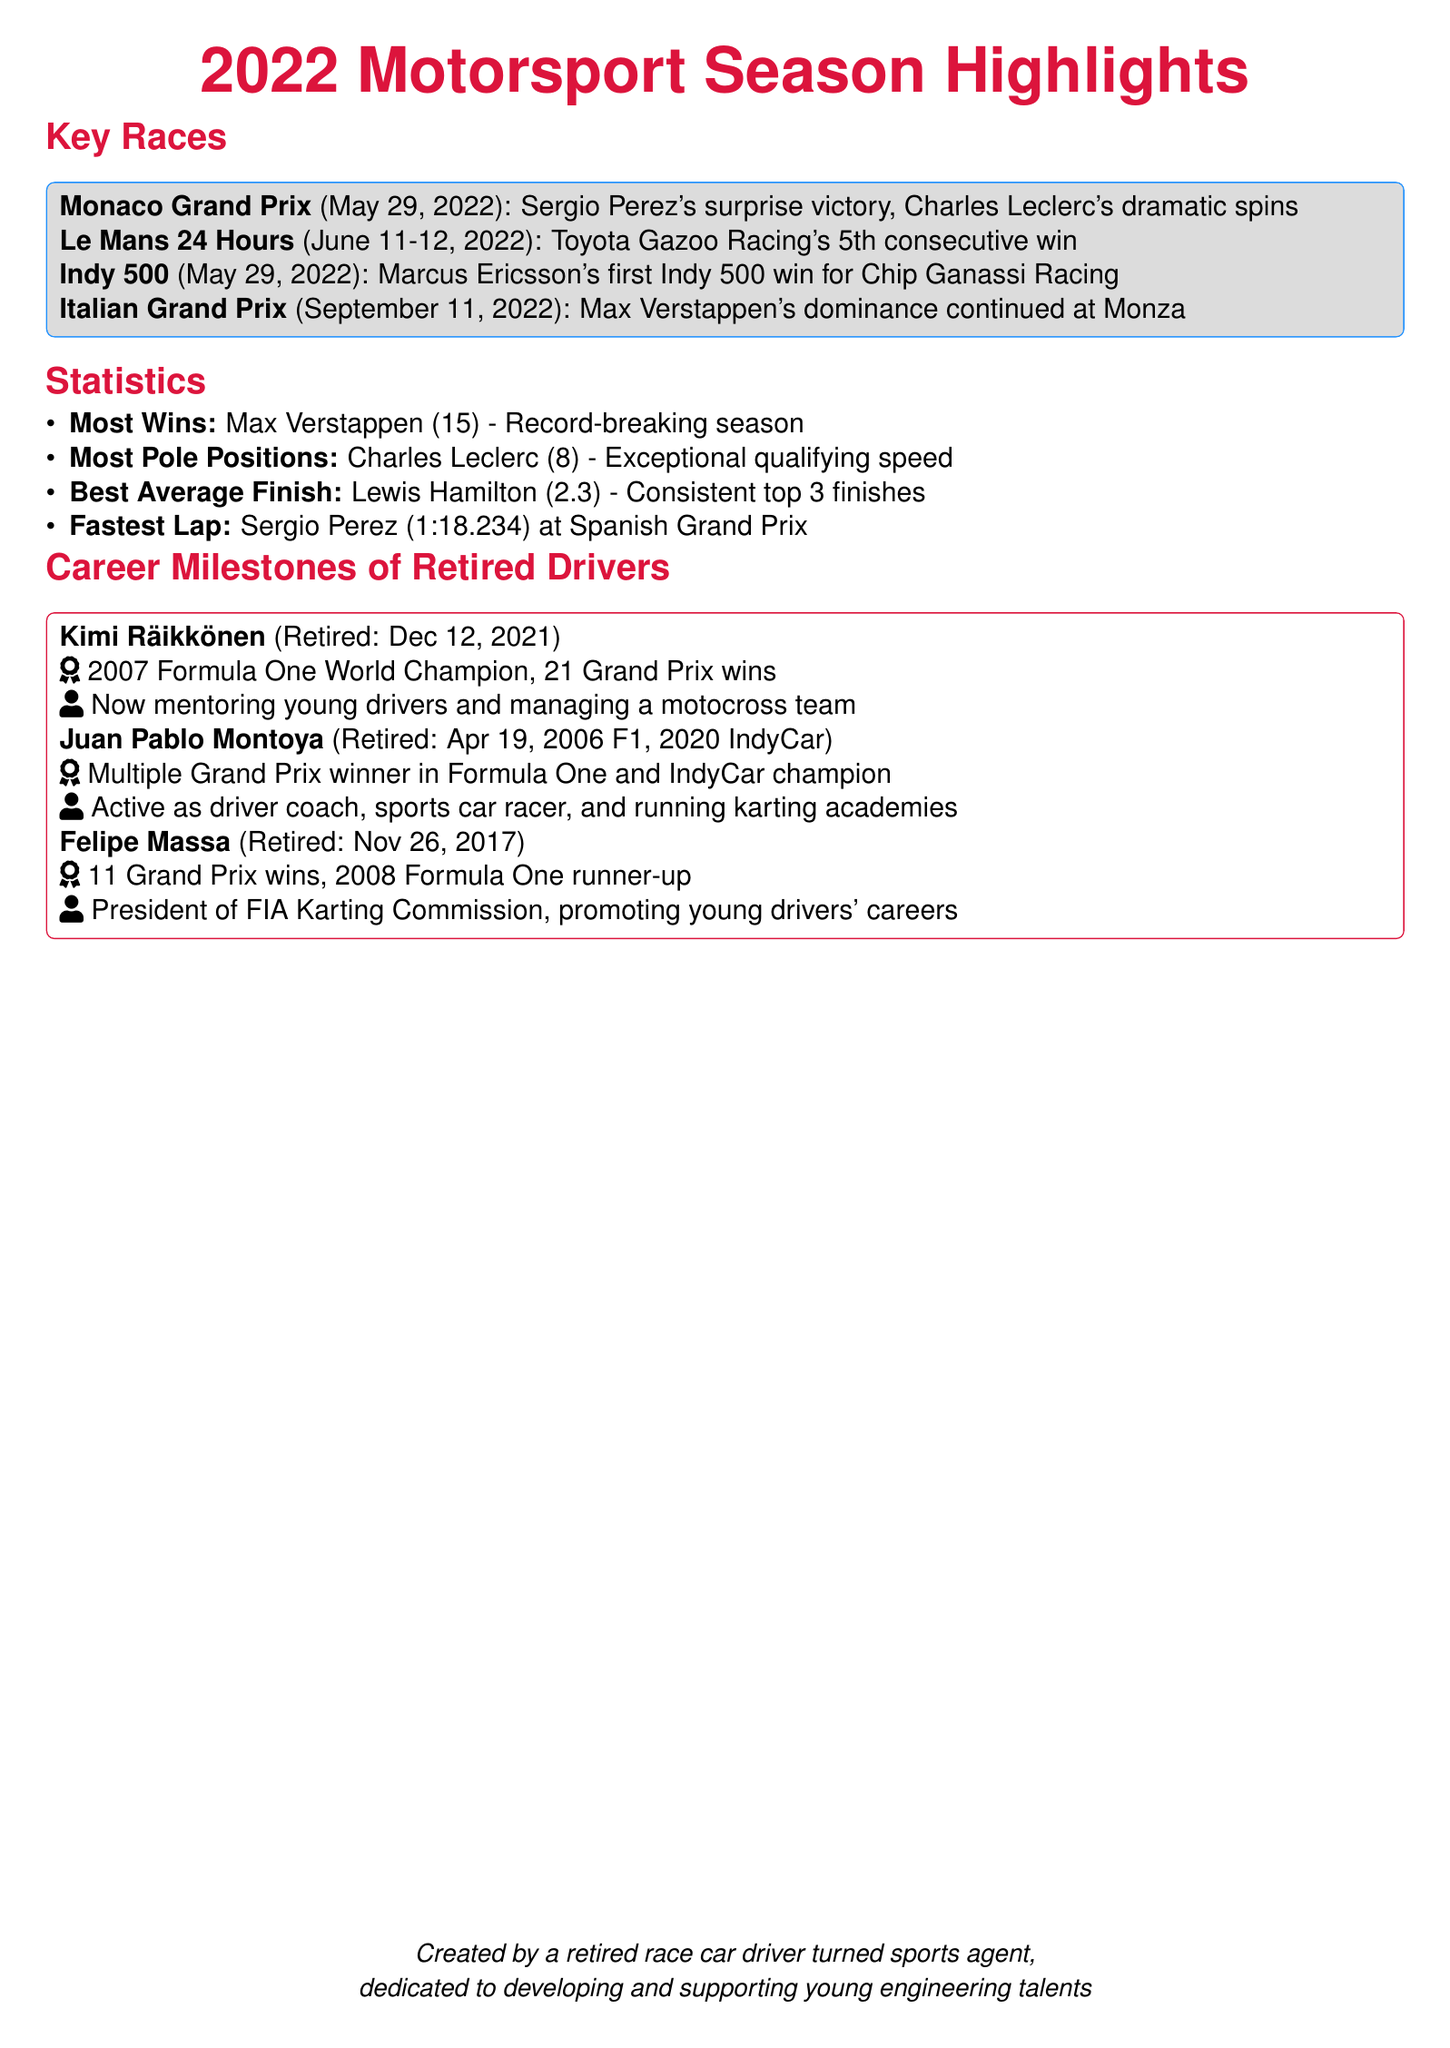What was the surprise victory at the Monaco Grand Prix? Sergio Perez's unexpected win is highlighted in the key races section.
Answer: Sergio Perez Who had the most pole positions in 2022? The statistics section states that Charles Leclerc had the most pole positions.
Answer: Charles Leclerc What significant race took place on May 29, 2022? The document lists both the Monaco Grand Prix and Indy 500 occurring on this date.
Answer: Indy 500 How many wins did Max Verstappen achieve in the 2022 season? The statistics section explicitly mentions that he had 15 wins, a record-breaking season.
Answer: 15 What was Kimi Räikkönen's career milestone? His championship and career wins are noted as significant achievements in the retired drivers' section.
Answer: 2007 Formula One World Champion, 21 Grand Prix wins Who is Felipe Massa currently associated with in motorsports? He is noted to be the President of the FIA Karting Commission, promoting young drivers.
Answer: FIA Karting Commission Which race featured Toyota Gazoo Racing's consecutive win? The Le Mans 24 Hours is mentioned for its historic win streak in the key races section.
Answer: Le Mans 24 Hours What was the fastest lap time in the Spanish Grand Prix? The statistics section lists Sergio Perez's fastest lap as being 1:18.234.
Answer: 1:18.234 What is Juan Pablo Montoya's current role in motorsports? He is described as active as a driver coach and in karting academies.
Answer: Driver coach, sports car racer 